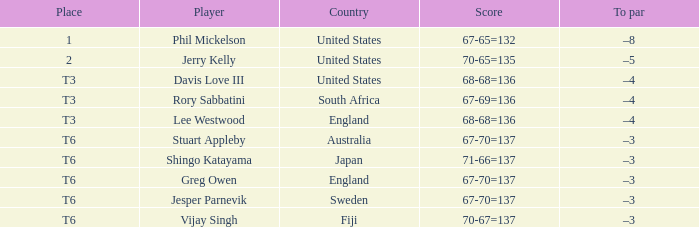Name the place for score of 67-70=137 and stuart appleby T6. 